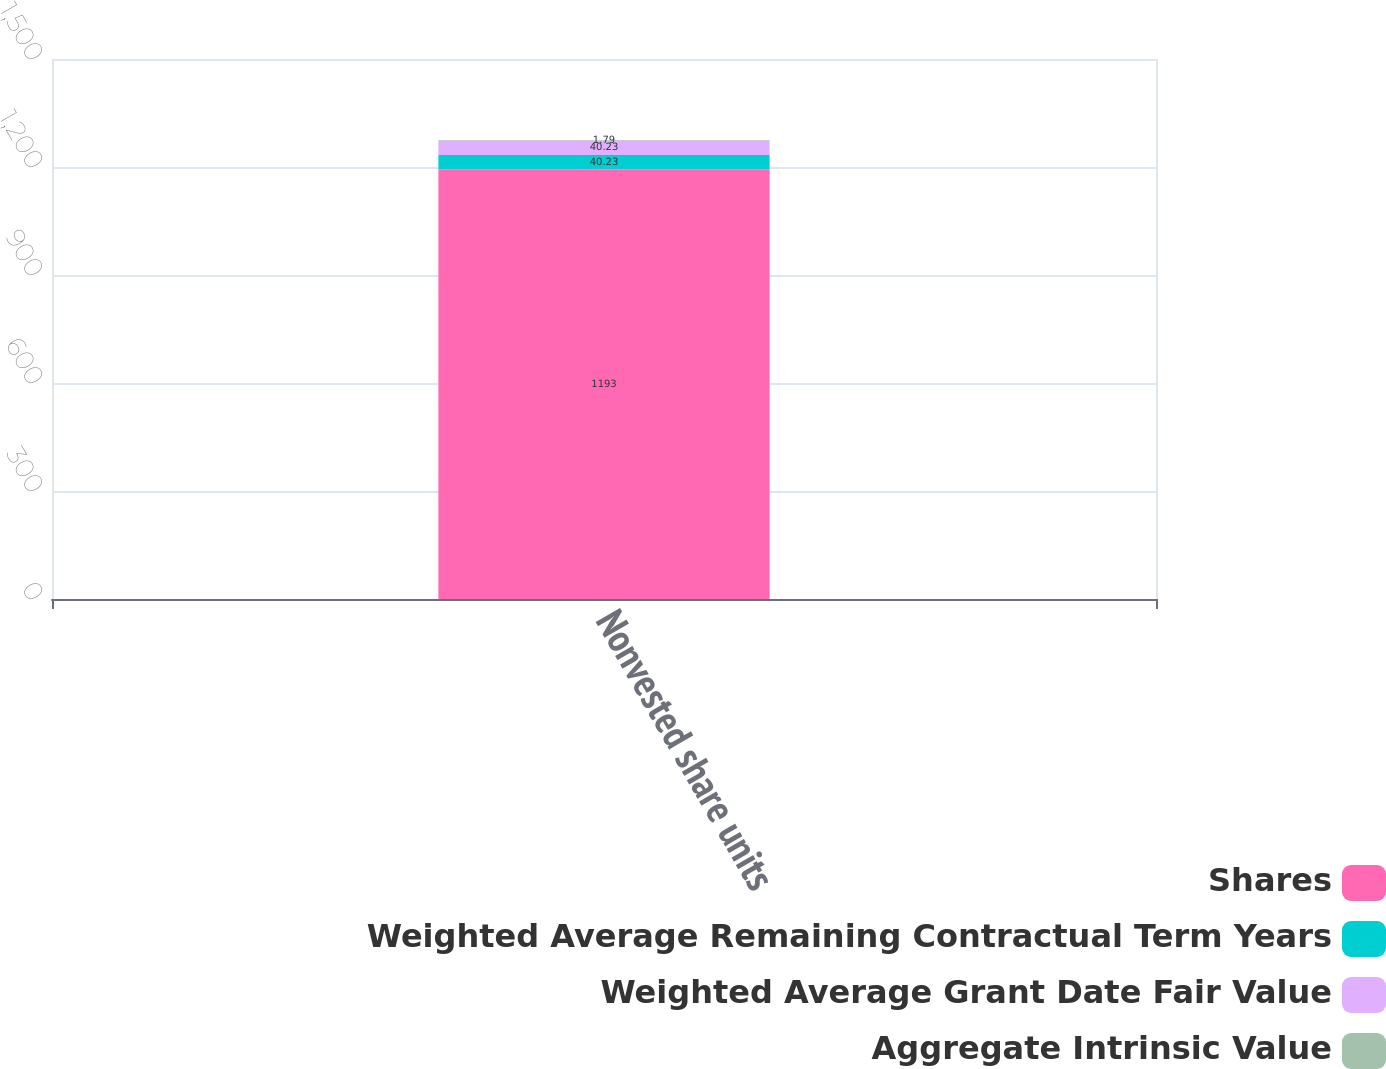Convert chart to OTSL. <chart><loc_0><loc_0><loc_500><loc_500><stacked_bar_chart><ecel><fcel>Nonvested share units<nl><fcel>Shares<fcel>1193<nl><fcel>Weighted Average Remaining Contractual Term Years<fcel>40.23<nl><fcel>Weighted Average Grant Date Fair Value<fcel>40.23<nl><fcel>Aggregate Intrinsic Value<fcel>1.79<nl></chart> 